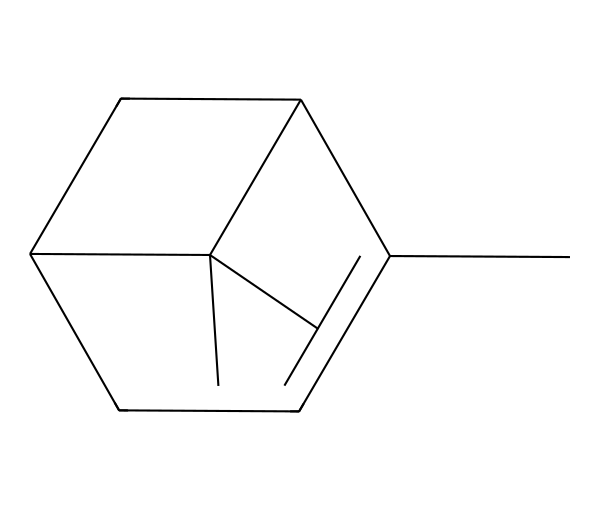What is the total number of carbon atoms in this compound? To determine the total number of carbon atoms, we can analyze the given SMILES representation. In the SMILES CC1=CCC2CC1C2(C), each 'C' corresponds to a carbon atom. Counting these gives us a total of 10 carbon atoms.
Answer: 10 How many double bonds are present in this molecule? Examining the SMILES representation, we can identify the double bond indicated by '=' in 'C1=CCC'. This means there is one double bond in the entire structure of the molecule.
Answer: 1 What type of compound is represented by this chemical? Based on its structure and classification, this molecule is a terpene. Terpenes are a large class of organic compounds, and the presence of its characteristic structural elements indicates it falls under this category.
Answer: terpene What functional groups are present? In reviewing the structure of the molecule, it does not contain any functional groups like hydroxyl, carbonyl, or carboxyl groups. The compound mainly consists of carbon and hydrogen without additional functional groups.
Answer: none How does this compound's structure contribute to its fragrance? The structure of this compound, which contains a specific arrangement of carbon atoms in a cyclic and branched form, is characteristic of aromatic compounds. This structure allows for the release of volatile organic compounds that contribute to its pine scent.
Answer: cyclic structure What is the molecular formula derived from this SMILES? By analyzing the counts of carbon and hydrogen from the SMILES, we derive the molecular formula C10H16. The count of 10 carbon atoms and 16 hydrogen atoms formulates the full molecular formula.
Answer: C10H16 